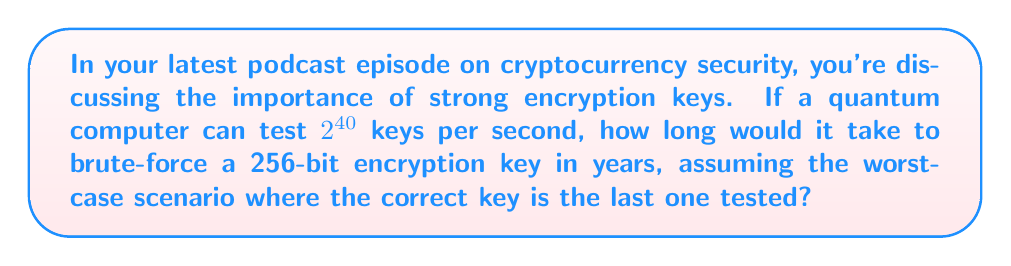Provide a solution to this math problem. Let's approach this step-by-step:

1) A 256-bit key has $2^{256}$ possible combinations.

2) The quantum computer can test $2^{40}$ keys per second.

3) To find the time in seconds, we divide the total number of keys by the number of keys tested per second:

   $$\text{Time (in seconds)} = \frac{2^{256}}{2^{40}}$$

4) This can be simplified to:

   $$\text{Time (in seconds)} = 2^{256-40} = 2^{216}$$

5) To convert seconds to years, we need to divide by the number of seconds in a year:
   
   $$\text{Time (in years)} = \frac{2^{216}}{60 \times 60 \times 24 \times 365.25}$$

   (We use 365.25 to account for leap years)

6) Let's calculate this:
   
   $$\text{Time (in years)} = \frac{2^{216}}{31,557,600} \approx 2.6815 \times 10^{58}$$

7) This number is so large that it's difficult to comprehend. To put it in perspective, it's many, many times larger than the estimated age of the universe (which is about $13.8 \times 10^9$ years).
Answer: $2.6815 \times 10^{58}$ years 